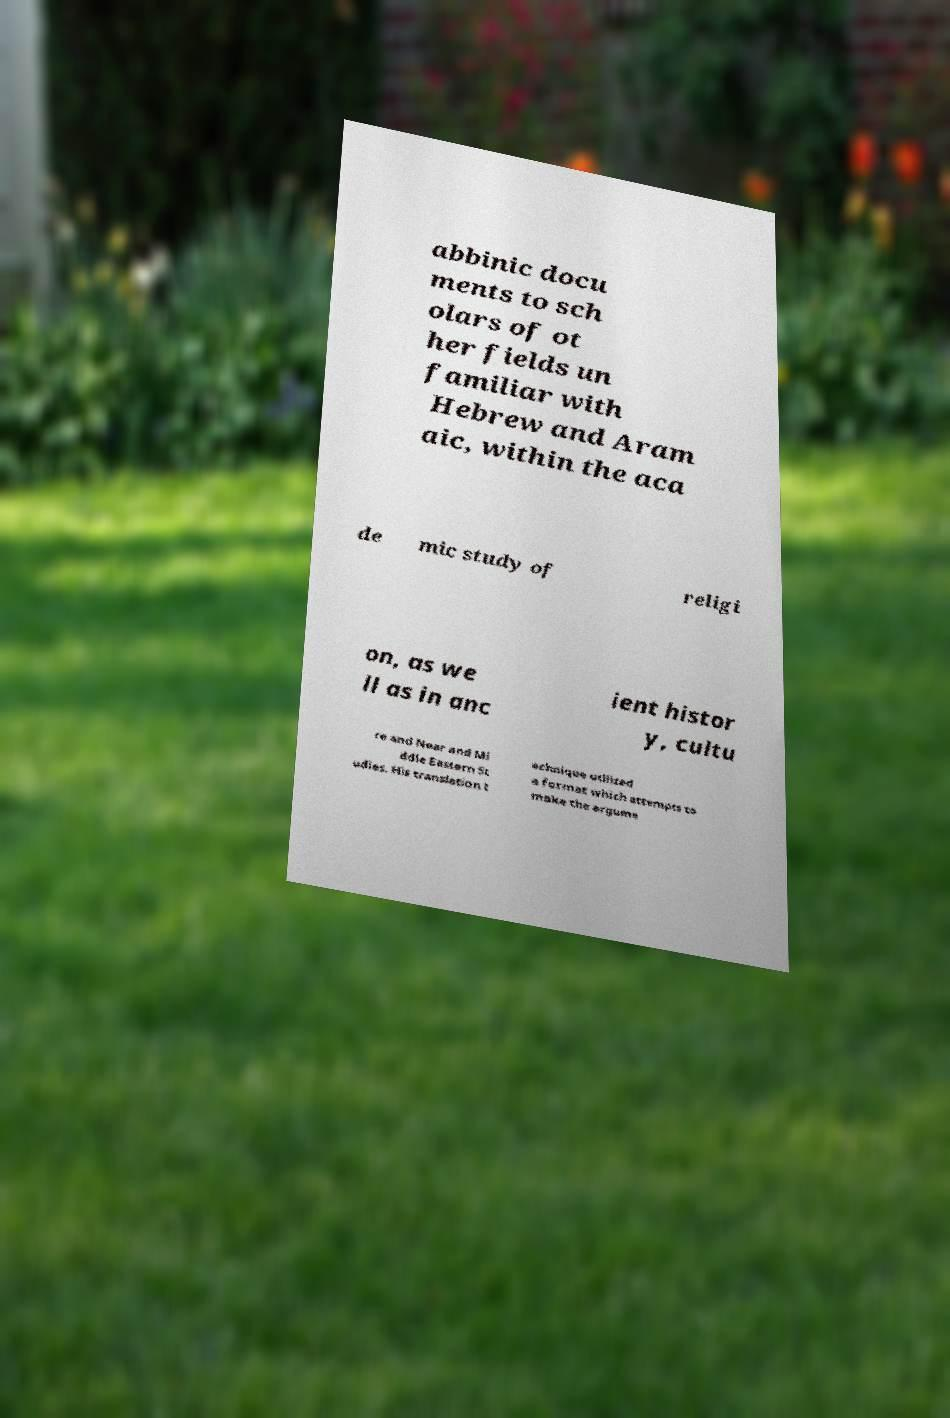Please identify and transcribe the text found in this image. abbinic docu ments to sch olars of ot her fields un familiar with Hebrew and Aram aic, within the aca de mic study of religi on, as we ll as in anc ient histor y, cultu re and Near and Mi ddle Eastern St udies. His translation t echnique utilized a format which attempts to make the argume 